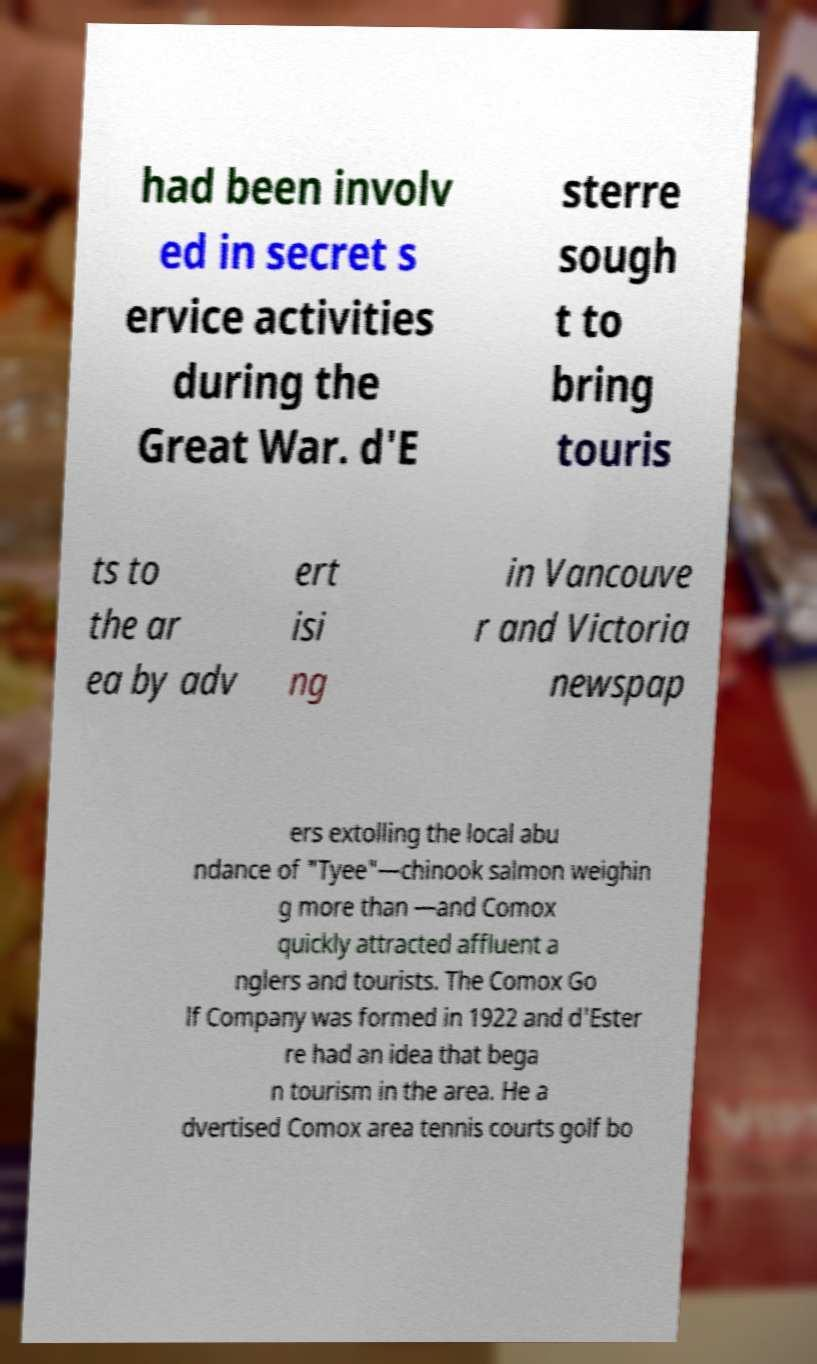Please identify and transcribe the text found in this image. had been involv ed in secret s ervice activities during the Great War. d'E sterre sough t to bring touris ts to the ar ea by adv ert isi ng in Vancouve r and Victoria newspap ers extolling the local abu ndance of "Tyee"—chinook salmon weighin g more than —and Comox quickly attracted affluent a nglers and tourists. The Comox Go lf Company was formed in 1922 and d'Ester re had an idea that bega n tourism in the area. He a dvertised Comox area tennis courts golf bo 